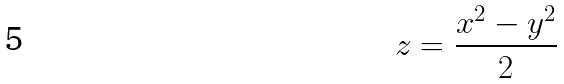<formula> <loc_0><loc_0><loc_500><loc_500>z = \frac { x ^ { 2 } - y ^ { 2 } } { 2 }</formula> 